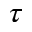<formula> <loc_0><loc_0><loc_500><loc_500>\tau</formula> 